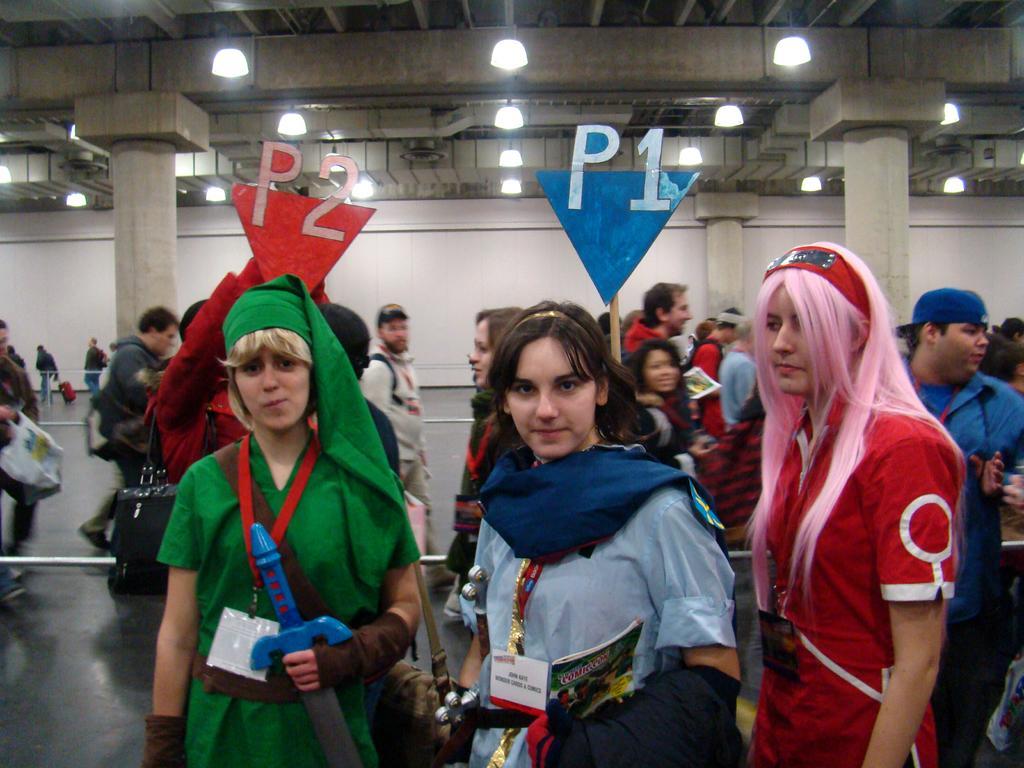Can you describe this image briefly? In this image we can see people wearing costumes and holding boards. In the background there is a wall. At the top there are lights. 